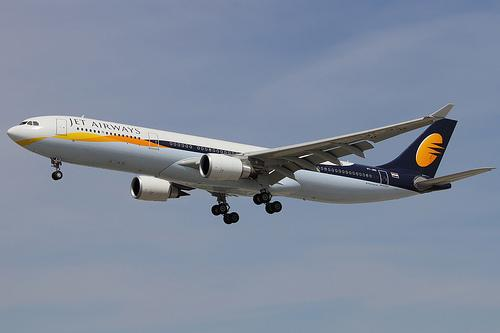Mention the notable features on the wings of the airplane. The wings of the airplane have a large jet engine, wing landing gear opening, and a long silver wing extending from the aircraft. What is the state of the airplane in the image? The airplane is flying in the sky with no issues. Identify the colors present on the tail fin of the airplane. The tail fin of the airplane has blue and yellow colors. List the different colors present on the airplane's body. The airplane's body has white, yellow, orange, and blue colors. Can you identify the condition of the landing gear in the image? The landing gear is coming down, with the wheels visible and having no issues. What type of airplane is shown in the image and which airline does it belong to? The image shows a jet airplane belonging to Jet Airways, with a white, yellow, orange, and blue color scheme. What are the color schemes of the plane's engines? The plane's engines have a white color scheme. Describe the windows and doors on the airplane. The airplane has planes passenger windows and a closed passenger door, along with cockpit windows at the very front of the plane. Describe the weather and sky conditions in the image. The image features gray, cloudy skies with fluffy white clouds. It appears to be a cloudy day. Mention any noticeable logos or markings on the airplane. There is a yellow sun logo on a blue background and the airline logo in blue on the front of the plane. Can you locate a large green dinosaur sitting on the wing of the airplane? No, it's not mentioned in the image. Are the clouds in the background pink and purple? The background is described as having "gray cloudy skies" and "fluffy white clouds." There's no mention of pink and purple clouds. 